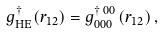<formula> <loc_0><loc_0><loc_500><loc_500>g _ { \text {HE} } ^ { \dagger } ( r _ { 1 2 } ) = g _ { 0 0 0 } ^ { \dagger \text { } 0 0 } \left ( r _ { 1 2 } \right ) ,</formula> 